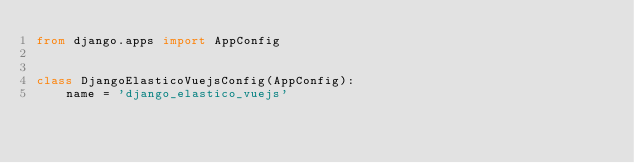Convert code to text. <code><loc_0><loc_0><loc_500><loc_500><_Python_>from django.apps import AppConfig


class DjangoElasticoVuejsConfig(AppConfig):
    name = 'django_elastico_vuejs'
</code> 